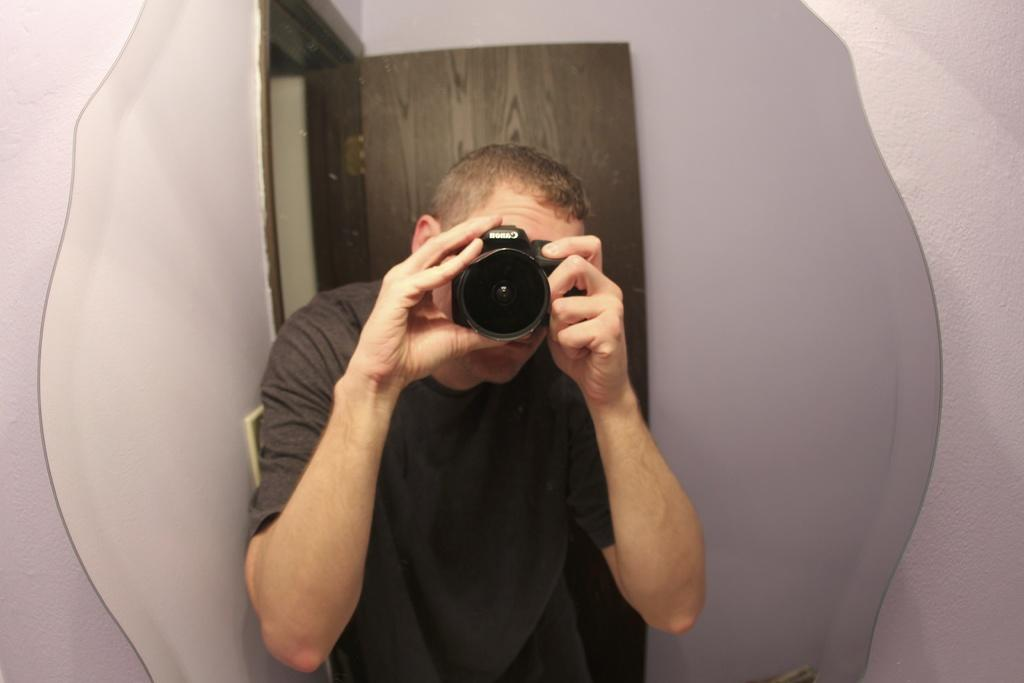What is the main subject of the image? There is a person in the image. What is the person holding in the image? The person is holding a camera. What can be seen in the background of the image? There is a door and a wall in the background of the image. What type of vest is the person wearing in the image? There is no vest visible in the image; the person is holding a camera. What type of apparel is the person using to rest in the image? There is no apparel or resting activity depicted in the image; the person is holding a camera. 